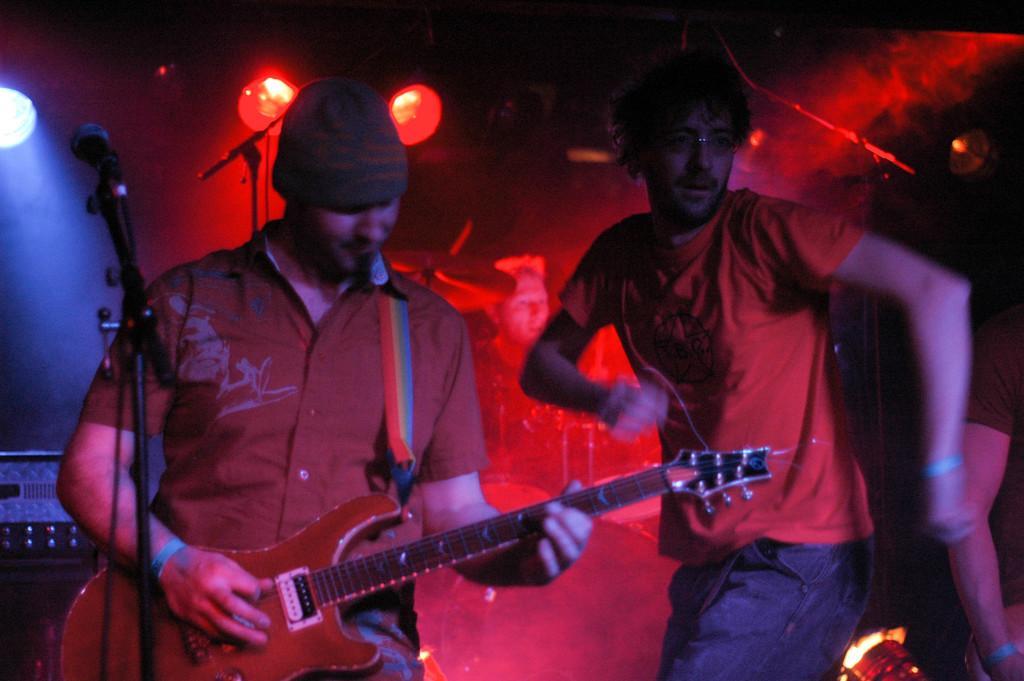Could you give a brief overview of what you see in this image? In this image i can see a person standing and holding a guitar in his hand, I can see a microphone in front of him. To the right of the image i can see another person standing. In the background i can see lights. 